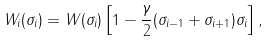<formula> <loc_0><loc_0><loc_500><loc_500>W _ { i } ( \sigma _ { i } ) = W ( \sigma _ { i } ) \left [ 1 - \frac { \gamma } { 2 } ( \sigma _ { i - 1 } + \sigma _ { i + 1 } ) \sigma _ { i } \right ] ,</formula> 